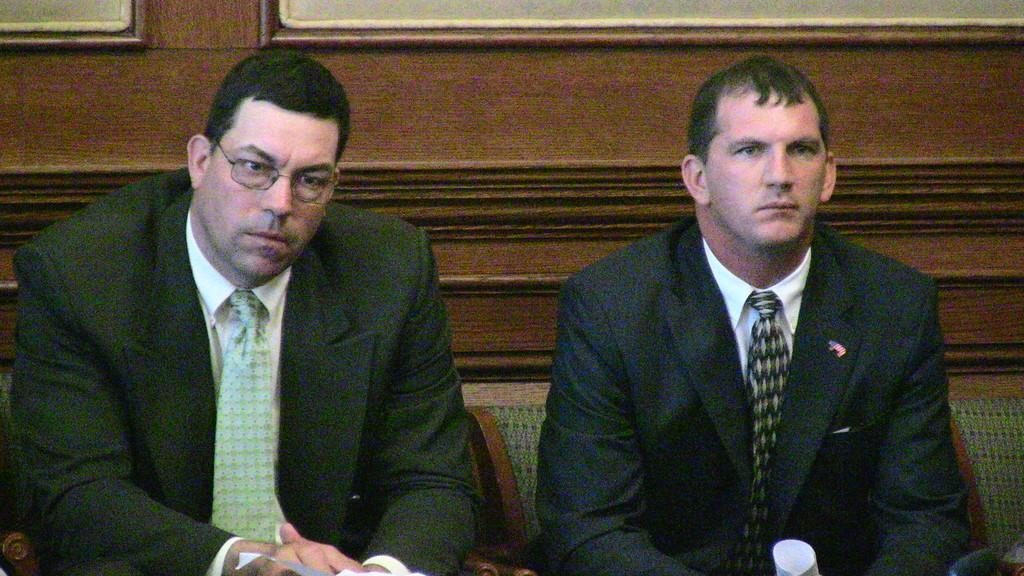How many people are in the image? There are persons in the image. What are the persons wearing? The persons are wearing coats. What are the persons doing in the image? The persons are sitting on chairs. What can be seen in the background of the image? There is a wall in the background of the image. What type of creature is playing the horn in the image? There is no creature playing a horn in the image; it does not depict any musical instruments or creatures. 